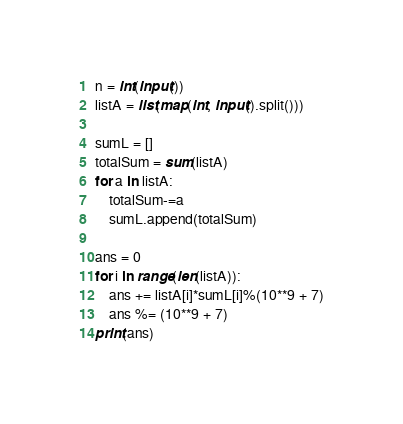Convert code to text. <code><loc_0><loc_0><loc_500><loc_500><_Python_>n = int(input())
listA = list(map(int, input().split()))

sumL = []
totalSum = sum(listA)
for a in listA:
    totalSum-=a
    sumL.append(totalSum)

ans = 0
for i in range(len(listA)):
    ans += listA[i]*sumL[i]%(10**9 + 7)
    ans %= (10**9 + 7)
print(ans)</code> 